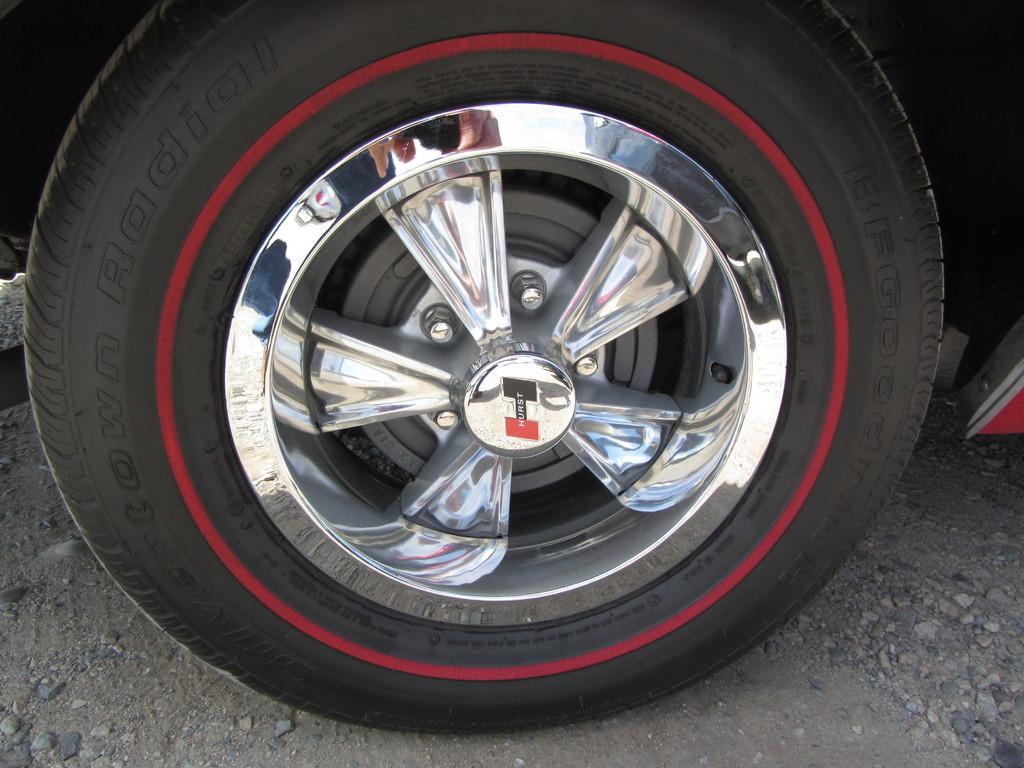Please provide a concise description of this image. In the center of the image a wheel is present. At the bottom of the image ground is there. 